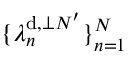Convert formula to latex. <formula><loc_0><loc_0><loc_500><loc_500>\{ \lambda _ { n } ^ { d , \perp N ^ { \prime } } \} _ { n = 1 } ^ { N }</formula> 